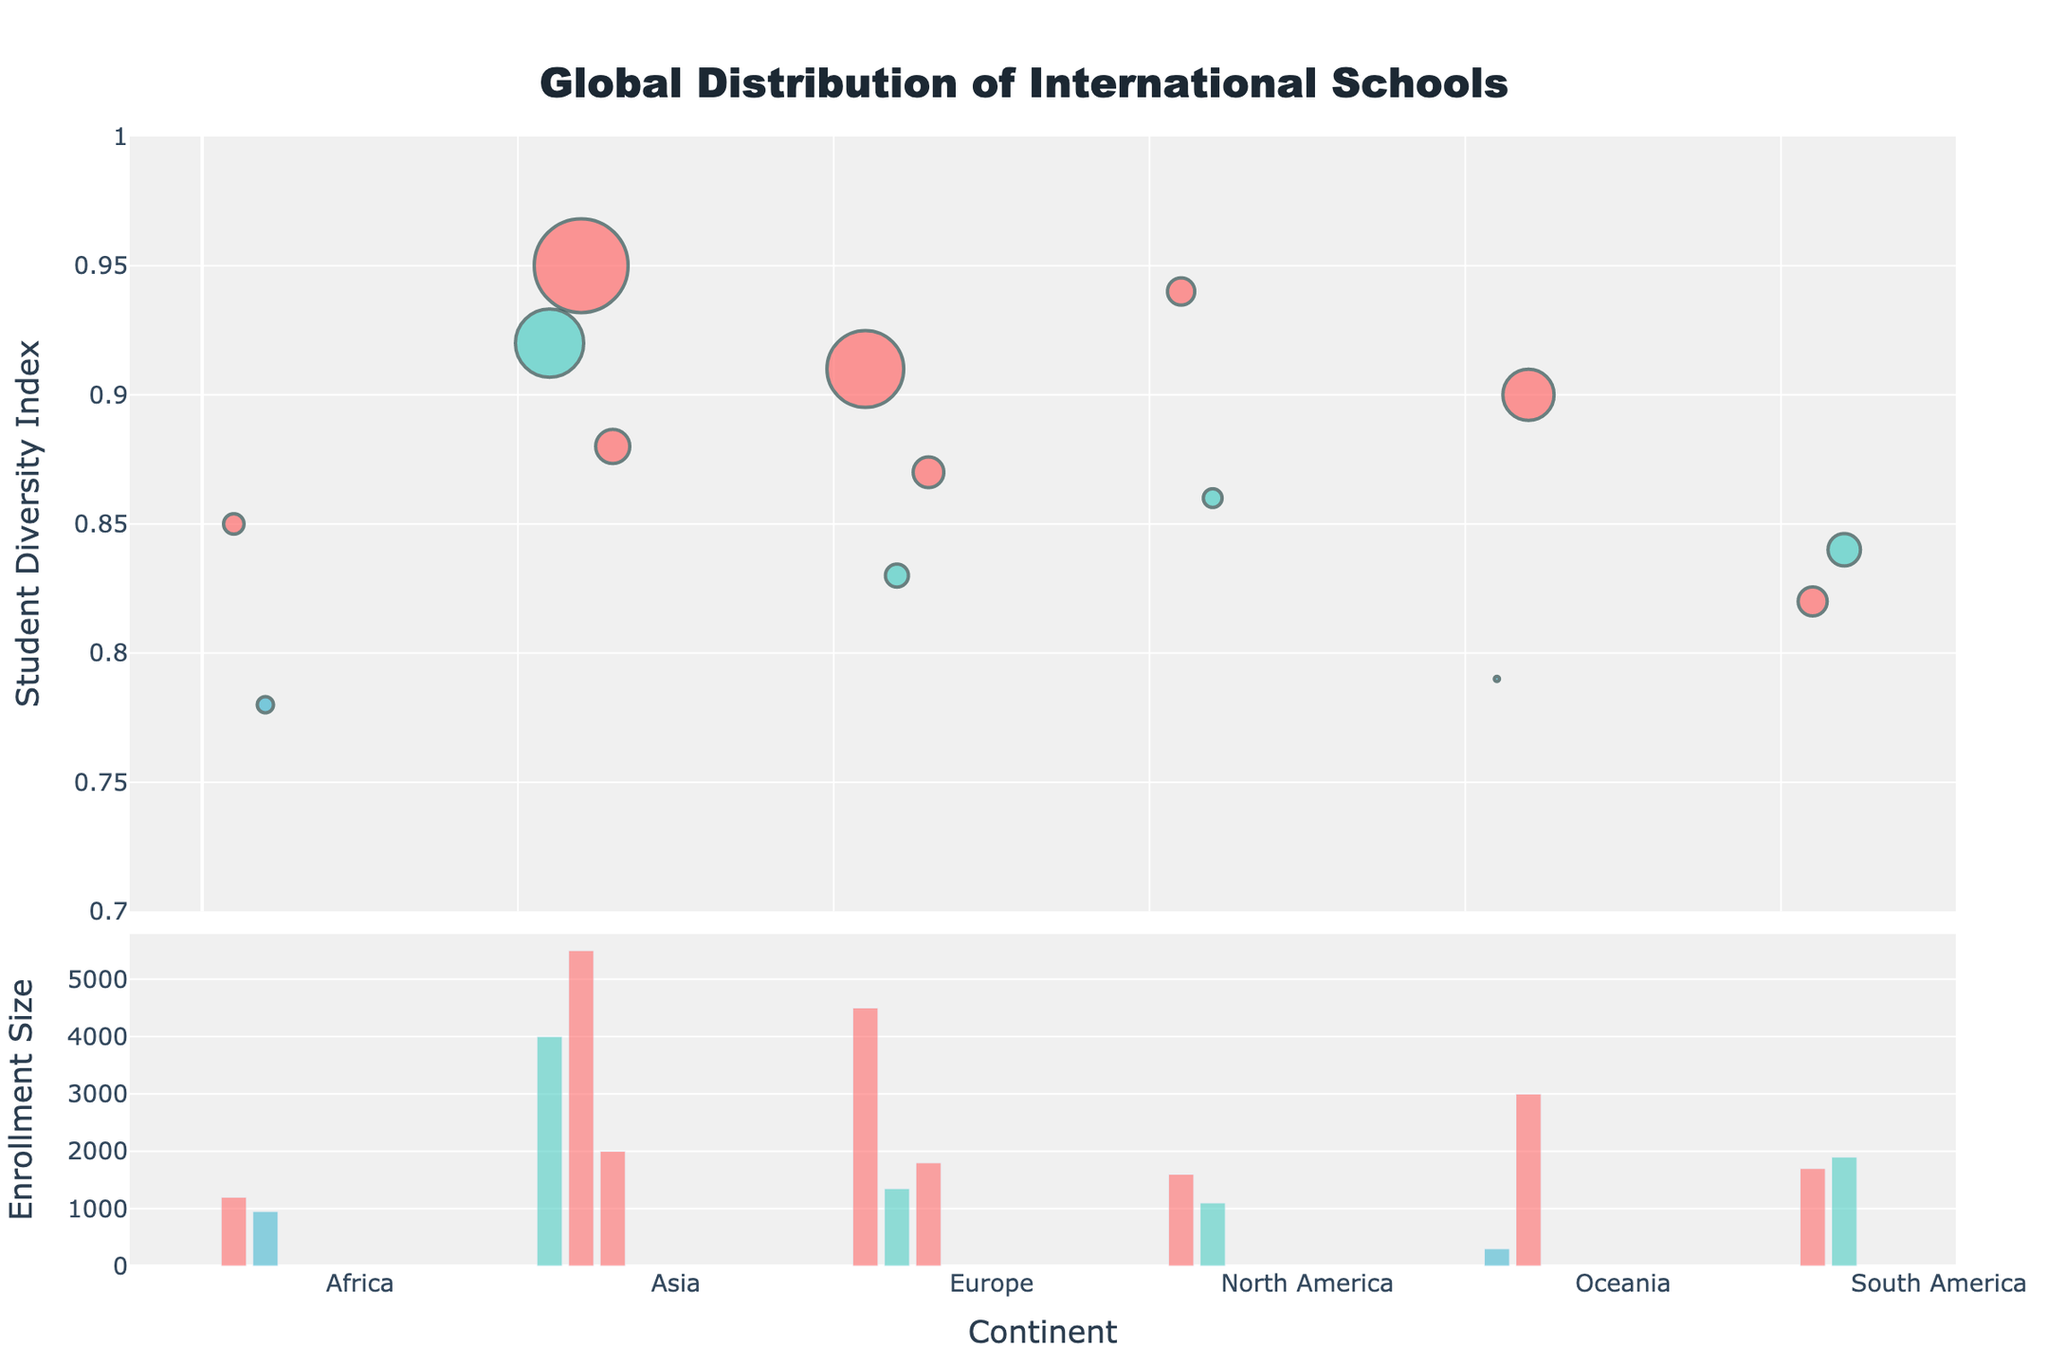What's the title of the plot? The title is usually located at the top of the plot and is meant to give an overview of what the plot represents.
Answer: Global Distribution of International Schools Which continent has the highest number of international schools represented in the figure? Count the number of data points (schools) within each continent on the x-axis.
Answer: Asia What is the enrollment size of the Singapore American School? Hover over the data point representing the Singapore American School (Asia, Position 1) to see the details, including its enrollment size.
Answer: 4000 Which curriculum type is more prevalent among the international schools in Europe? Look at the color of the markers corresponding to European schools and match them to the curriculum type legend.
Answer: IB What is the average student diversity index for schools in North America? Find the data points for North America, note their student diversity indices, and calculate the average: (0.94 + 0.86) / 2.
Answer: 0.90 Which school has the largest enrollment size? Find the bar in the lower part of the plot that reaches the highest point. Hover over it to get the school's enrollment size.
Answer: United World College of South East Asia Compare the student diversity index of the International School of Western Australia and the American School of The Hague. Which one is higher? Locate the two schools and compare their y-values (Student Diversity) in the upper plot.
Answer: American School of The Hague What is the sum of the enrollment sizes for the schools in Africa? Add up the enrollment sizes for the two African schools: 1200 + 950.
Answer: 2150 How does the enrollment size distribution vary between Asia and Oceania? Compare the heights of the bars in the lower plot for schools in Asia and Oceania, indicating their enrollment sizes.
Answer: Asia has larger enrollment sizes overall Which continent shows the most diversity in student population based on the y-axis data (Student Diversity Index)? Look for the continent whose data points (markers) are closest to the top of the y-axis range (closer to 1).
Answer: Asia 